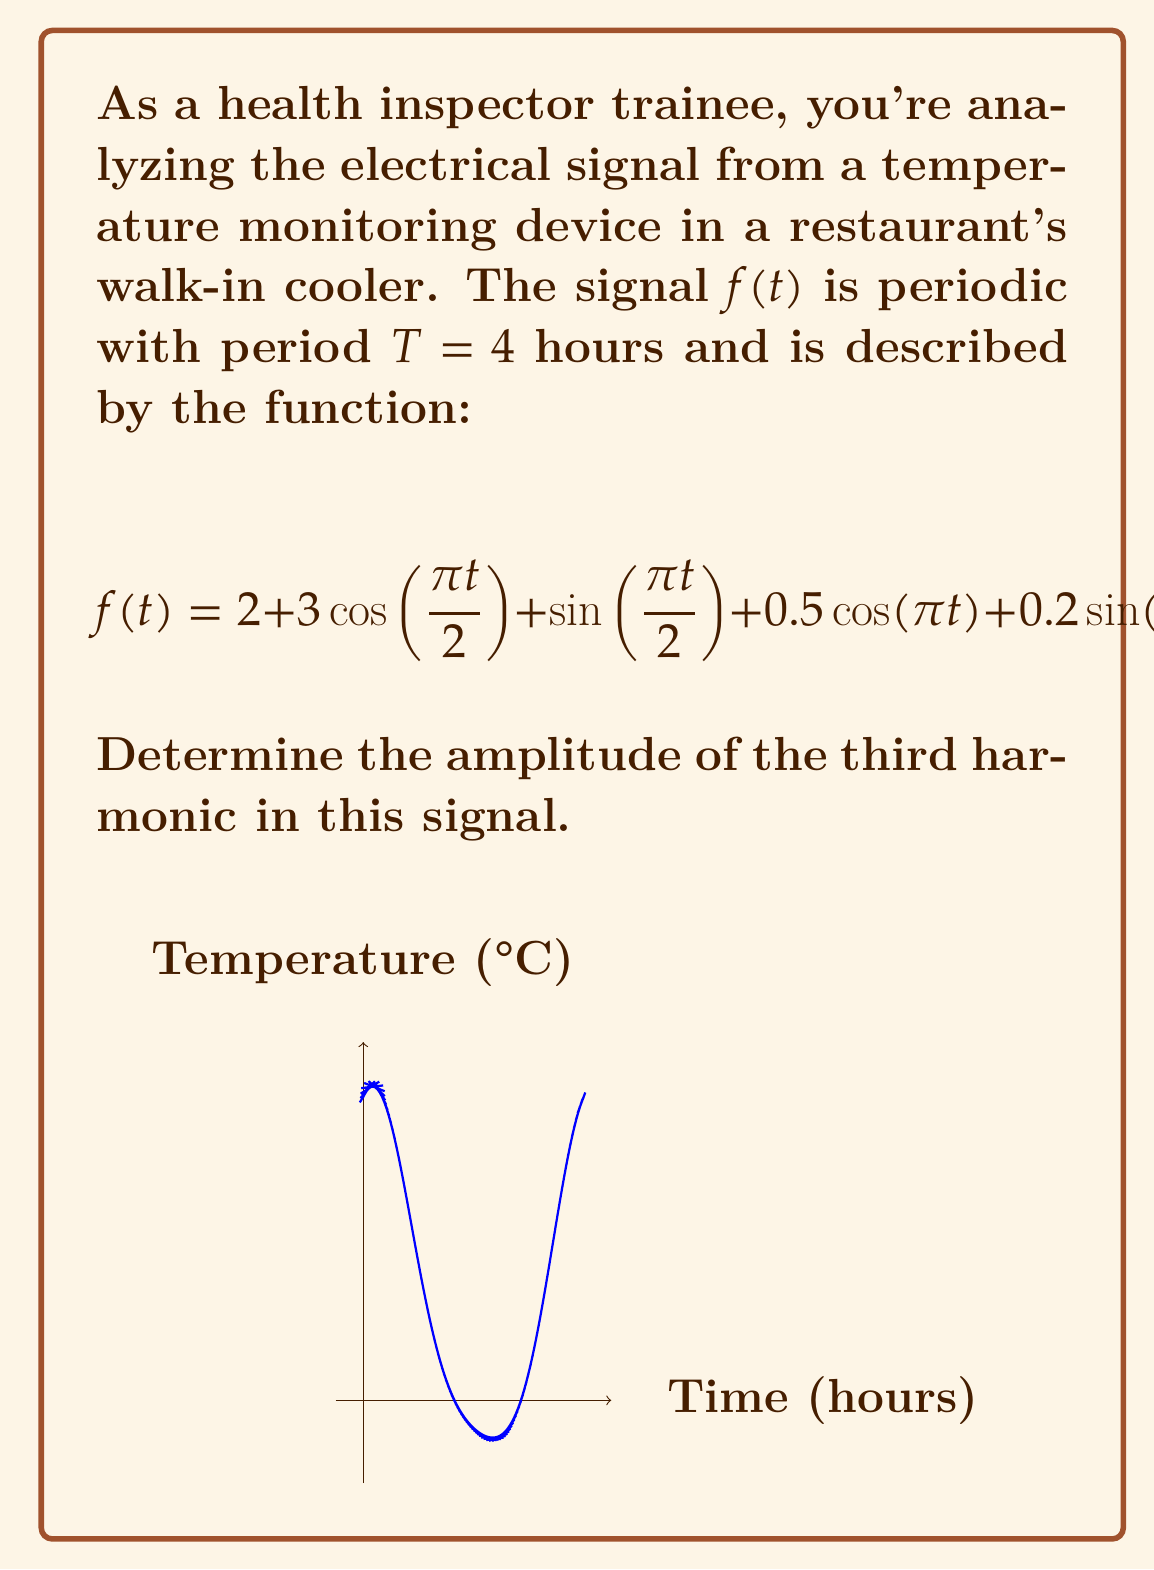Can you solve this math problem? To find the amplitude of the third harmonic, let's follow these steps:

1) First, recall that for a signal with period $T$, the fundamental frequency $\omega_0$ is given by:
   $$\omega_0 = \frac{2\pi}{T} = \frac{2\pi}{4} = \frac{\pi}{2}$$

2) The general form of a Fourier series is:
   $$f(t) = a_0 + \sum_{n=1}^{\infty} [a_n \cos(n\omega_0 t) + b_n \sin(n\omega_0 t)]$$

3) Comparing our signal to this form:
   $$f(t) = 2 + 3\cos(\frac{\pi t}{2}) + \sin(\frac{\pi t}{2}) + 0.5\cos(\pi t) + 0.2\sin(\pi t)$$

   We can identify:
   $a_0 = 2$
   $a_1 = 3$, $b_1 = 1$
   $a_2 = 0.5$, $b_2 = 0.2$
   All higher harmonics have zero coefficients.

4) The third harmonic (n = 3) has zero coefficients: $a_3 = 0$, $b_3 = 0$

5) The amplitude of a harmonic is given by $\sqrt{a_n^2 + b_n^2}$

6) Therefore, the amplitude of the third harmonic is:
   $$\sqrt{a_3^2 + b_3^2} = \sqrt{0^2 + 0^2} = 0$$
Answer: 0 